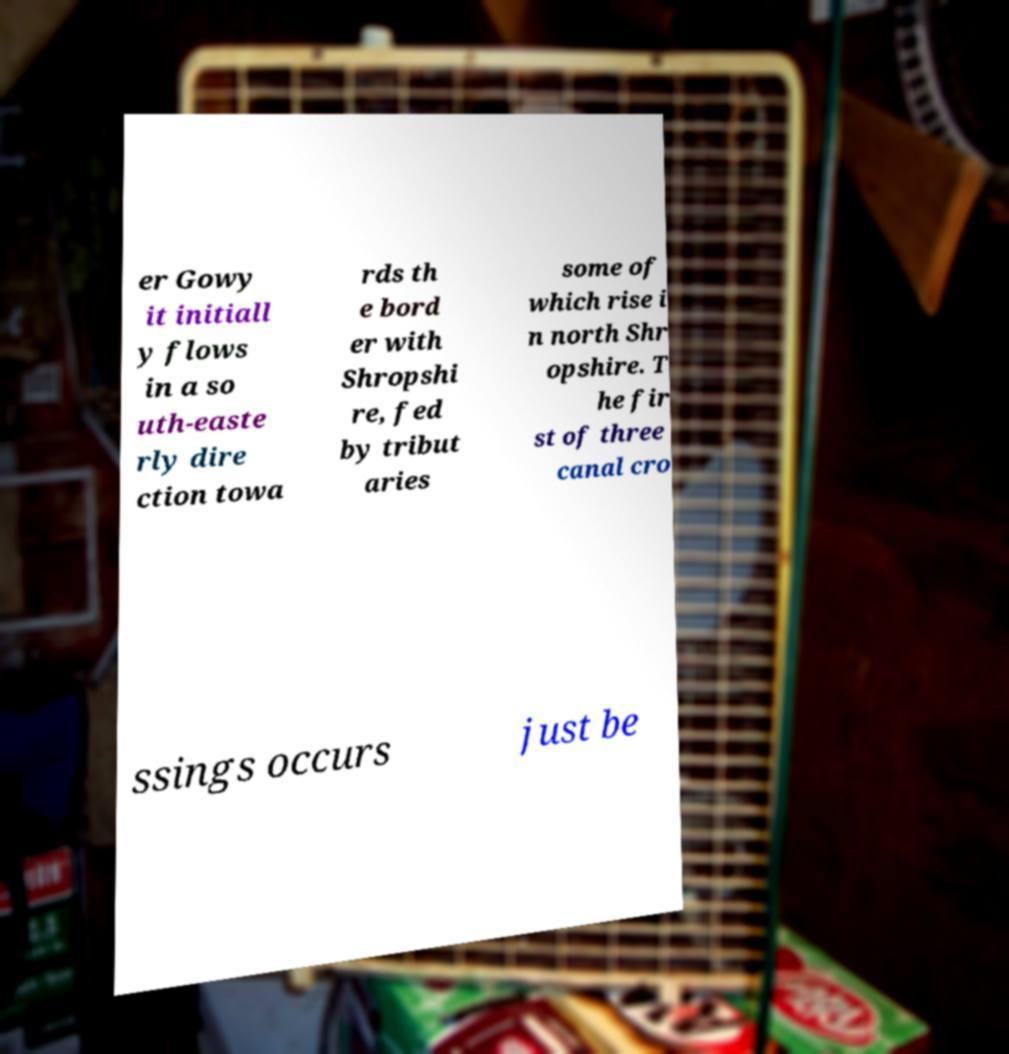Please read and relay the text visible in this image. What does it say? er Gowy it initiall y flows in a so uth-easte rly dire ction towa rds th e bord er with Shropshi re, fed by tribut aries some of which rise i n north Shr opshire. T he fir st of three canal cro ssings occurs just be 